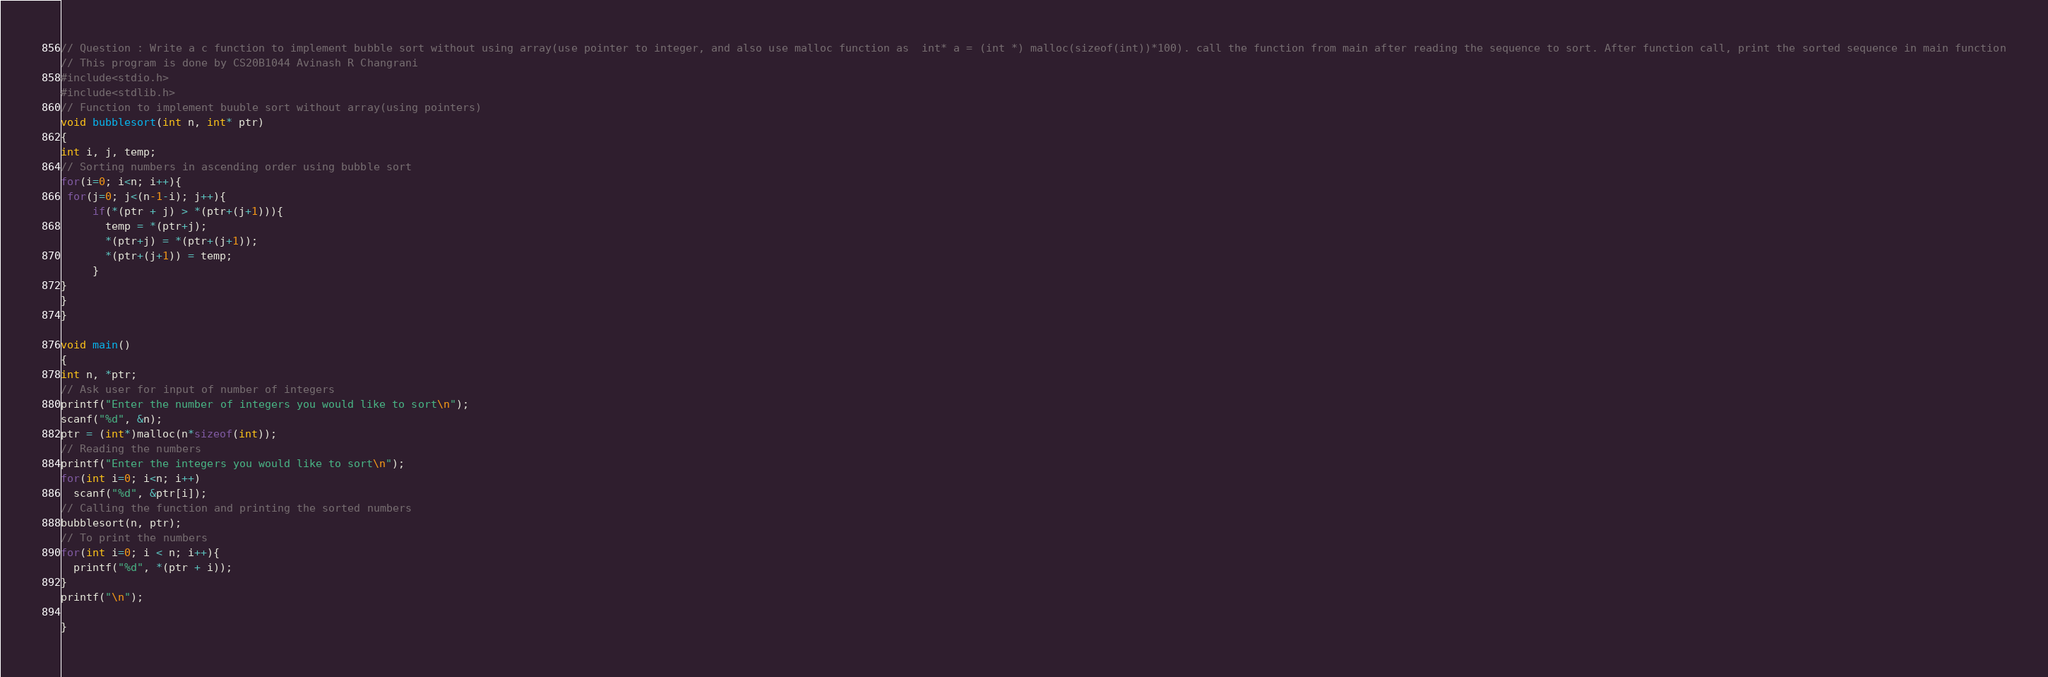<code> <loc_0><loc_0><loc_500><loc_500><_C_>// Question : Write a c function to implement bubble sort without using array(use pointer to integer, and also use malloc function as  int* a = (int *) malloc(sizeof(int))*100). call the function from main after reading the sequence to sort. After function call, print the sorted sequence in main function
// This program is done by CS20B1044 Avinash R Changrani
#include<stdio.h>
#include<stdlib.h>
// Function to implement buuble sort without array(using pointers)
void bubblesort(int n, int* ptr)
{
int i, j, temp;
// Sorting numbers in ascending order using bubble sort
for(i=0; i<n; i++){
 for(j=0; j<(n-1-i); j++){
     if(*(ptr + j) > *(ptr+(j+1))){
       temp = *(ptr+j);
       *(ptr+j) = *(ptr+(j+1));
       *(ptr+(j+1)) = temp;
     }  
}    
}
}

void main()
{
int n, *ptr;
// Ask user for input of number of integers
printf("Enter the number of integers you would like to sort\n");
scanf("%d", &n);
ptr = (int*)malloc(n*sizeof(int)); 
// Reading the numbers
printf("Enter the integers you would like to sort\n");
for(int i=0; i<n; i++)
  scanf("%d", &ptr[i]);
// Calling the function and printing the sorted numbers
bubblesort(n, ptr);
// To print the numbers
for(int i=0; i < n; i++){
  printf("%d", *(ptr + i));
}
printf("\n");

}

</code> 